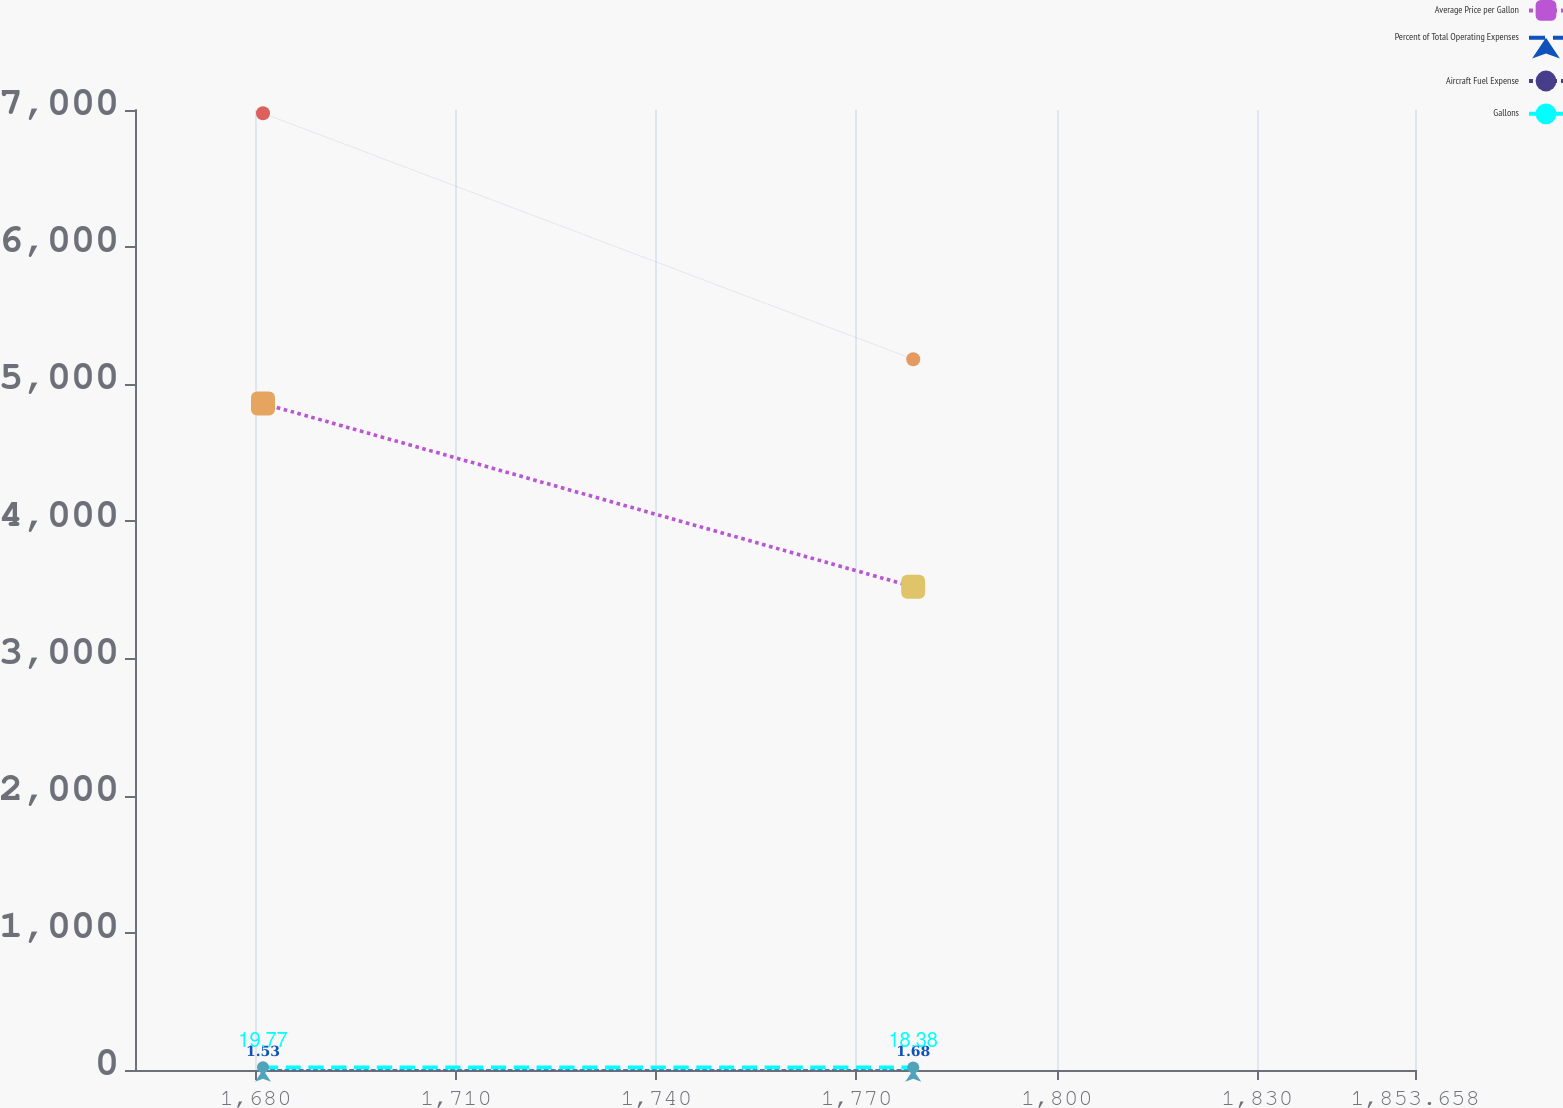Convert chart to OTSL. <chart><loc_0><loc_0><loc_500><loc_500><line_chart><ecel><fcel>Average Price per Gallon<fcel>Percent of Total Operating Expenses<fcel>Aircraft Fuel Expense<fcel>Gallons<nl><fcel>1681.11<fcel>4859.51<fcel>1.53<fcel>6976.16<fcel>19.77<nl><fcel>1778.5<fcel>3523.29<fcel>1.68<fcel>5183.09<fcel>18.38<nl><fcel>1872.83<fcel>4997.96<fcel>1.59<fcel>7575.81<fcel>18.52<nl></chart> 